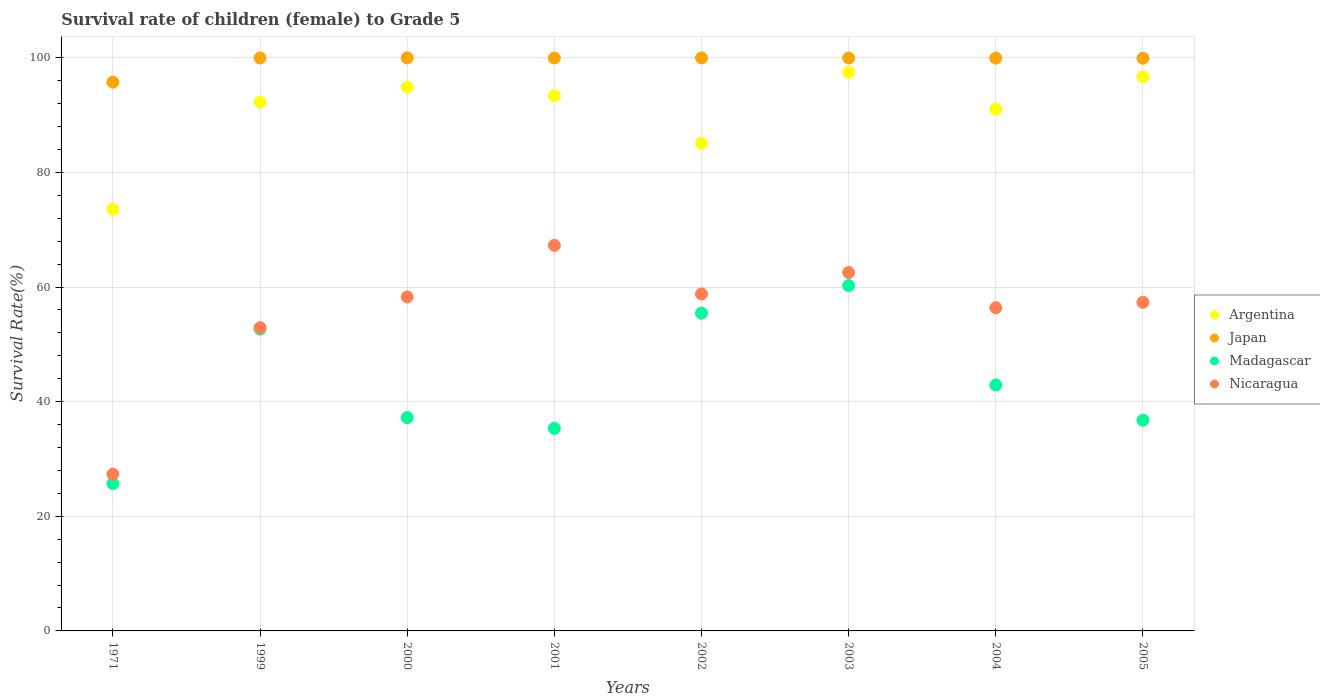How many different coloured dotlines are there?
Keep it short and to the point. 4. Is the number of dotlines equal to the number of legend labels?
Provide a short and direct response. Yes. What is the survival rate of female children to grade 5 in Argentina in 2000?
Your response must be concise. 94.89. Across all years, what is the maximum survival rate of female children to grade 5 in Argentina?
Keep it short and to the point. 97.47. Across all years, what is the minimum survival rate of female children to grade 5 in Madagascar?
Your response must be concise. 25.71. In which year was the survival rate of female children to grade 5 in Madagascar minimum?
Make the answer very short. 1971. What is the total survival rate of female children to grade 5 in Japan in the graph?
Ensure brevity in your answer.  795.5. What is the difference between the survival rate of female children to grade 5 in Japan in 2002 and that in 2004?
Provide a short and direct response. 0.04. What is the difference between the survival rate of female children to grade 5 in Argentina in 2003 and the survival rate of female children to grade 5 in Nicaragua in 2005?
Ensure brevity in your answer.  40.14. What is the average survival rate of female children to grade 5 in Argentina per year?
Your answer should be compact. 90.55. In the year 1999, what is the difference between the survival rate of female children to grade 5 in Madagascar and survival rate of female children to grade 5 in Japan?
Keep it short and to the point. -47.32. What is the ratio of the survival rate of female children to grade 5 in Japan in 2000 to that in 2005?
Provide a succinct answer. 1. Is the survival rate of female children to grade 5 in Japan in 1999 less than that in 2001?
Your answer should be very brief. No. What is the difference between the highest and the second highest survival rate of female children to grade 5 in Nicaragua?
Your answer should be very brief. 4.74. What is the difference between the highest and the lowest survival rate of female children to grade 5 in Argentina?
Give a very brief answer. 23.9. In how many years, is the survival rate of female children to grade 5 in Nicaragua greater than the average survival rate of female children to grade 5 in Nicaragua taken over all years?
Your response must be concise. 6. Is it the case that in every year, the sum of the survival rate of female children to grade 5 in Japan and survival rate of female children to grade 5 in Nicaragua  is greater than the survival rate of female children to grade 5 in Argentina?
Offer a terse response. Yes. Does the survival rate of female children to grade 5 in Japan monotonically increase over the years?
Provide a short and direct response. No. Is the survival rate of female children to grade 5 in Argentina strictly greater than the survival rate of female children to grade 5 in Nicaragua over the years?
Your answer should be very brief. Yes. Is the survival rate of female children to grade 5 in Nicaragua strictly less than the survival rate of female children to grade 5 in Argentina over the years?
Keep it short and to the point. Yes. How many years are there in the graph?
Offer a terse response. 8. Are the values on the major ticks of Y-axis written in scientific E-notation?
Offer a very short reply. No. Does the graph contain grids?
Keep it short and to the point. Yes. Where does the legend appear in the graph?
Give a very brief answer. Center right. How many legend labels are there?
Your answer should be very brief. 4. What is the title of the graph?
Your answer should be very brief. Survival rate of children (female) to Grade 5. What is the label or title of the X-axis?
Offer a very short reply. Years. What is the label or title of the Y-axis?
Provide a succinct answer. Survival Rate(%). What is the Survival Rate(%) in Argentina in 1971?
Give a very brief answer. 73.58. What is the Survival Rate(%) of Japan in 1971?
Provide a succinct answer. 95.75. What is the Survival Rate(%) in Madagascar in 1971?
Provide a short and direct response. 25.71. What is the Survival Rate(%) of Nicaragua in 1971?
Keep it short and to the point. 27.36. What is the Survival Rate(%) in Argentina in 1999?
Provide a succinct answer. 92.27. What is the Survival Rate(%) of Japan in 1999?
Keep it short and to the point. 99.98. What is the Survival Rate(%) in Madagascar in 1999?
Provide a short and direct response. 52.66. What is the Survival Rate(%) in Nicaragua in 1999?
Provide a succinct answer. 52.92. What is the Survival Rate(%) in Argentina in 2000?
Provide a succinct answer. 94.89. What is the Survival Rate(%) of Japan in 2000?
Ensure brevity in your answer.  99.99. What is the Survival Rate(%) in Madagascar in 2000?
Your response must be concise. 37.22. What is the Survival Rate(%) of Nicaragua in 2000?
Give a very brief answer. 58.27. What is the Survival Rate(%) of Argentina in 2001?
Make the answer very short. 93.36. What is the Survival Rate(%) in Japan in 2001?
Make the answer very short. 99.96. What is the Survival Rate(%) of Madagascar in 2001?
Your answer should be very brief. 35.35. What is the Survival Rate(%) of Nicaragua in 2001?
Make the answer very short. 67.28. What is the Survival Rate(%) in Argentina in 2002?
Offer a terse response. 85.08. What is the Survival Rate(%) in Japan in 2002?
Your answer should be very brief. 99.98. What is the Survival Rate(%) in Madagascar in 2002?
Give a very brief answer. 55.45. What is the Survival Rate(%) in Nicaragua in 2002?
Offer a very short reply. 58.8. What is the Survival Rate(%) of Argentina in 2003?
Keep it short and to the point. 97.47. What is the Survival Rate(%) of Japan in 2003?
Offer a very short reply. 99.97. What is the Survival Rate(%) in Madagascar in 2003?
Your answer should be very brief. 60.26. What is the Survival Rate(%) of Nicaragua in 2003?
Offer a terse response. 62.54. What is the Survival Rate(%) of Argentina in 2004?
Provide a succinct answer. 91.02. What is the Survival Rate(%) in Japan in 2004?
Your answer should be compact. 99.94. What is the Survival Rate(%) in Madagascar in 2004?
Ensure brevity in your answer.  42.91. What is the Survival Rate(%) in Nicaragua in 2004?
Offer a very short reply. 56.39. What is the Survival Rate(%) in Argentina in 2005?
Your response must be concise. 96.71. What is the Survival Rate(%) in Japan in 2005?
Offer a very short reply. 99.92. What is the Survival Rate(%) of Madagascar in 2005?
Your response must be concise. 36.77. What is the Survival Rate(%) in Nicaragua in 2005?
Offer a very short reply. 57.34. Across all years, what is the maximum Survival Rate(%) in Argentina?
Your answer should be compact. 97.47. Across all years, what is the maximum Survival Rate(%) of Japan?
Offer a terse response. 99.99. Across all years, what is the maximum Survival Rate(%) in Madagascar?
Offer a terse response. 60.26. Across all years, what is the maximum Survival Rate(%) in Nicaragua?
Give a very brief answer. 67.28. Across all years, what is the minimum Survival Rate(%) in Argentina?
Your response must be concise. 73.58. Across all years, what is the minimum Survival Rate(%) in Japan?
Ensure brevity in your answer.  95.75. Across all years, what is the minimum Survival Rate(%) in Madagascar?
Offer a very short reply. 25.71. Across all years, what is the minimum Survival Rate(%) in Nicaragua?
Provide a succinct answer. 27.36. What is the total Survival Rate(%) in Argentina in the graph?
Your answer should be very brief. 724.39. What is the total Survival Rate(%) in Japan in the graph?
Provide a short and direct response. 795.5. What is the total Survival Rate(%) in Madagascar in the graph?
Keep it short and to the point. 346.33. What is the total Survival Rate(%) of Nicaragua in the graph?
Offer a terse response. 440.89. What is the difference between the Survival Rate(%) of Argentina in 1971 and that in 1999?
Provide a short and direct response. -18.7. What is the difference between the Survival Rate(%) of Japan in 1971 and that in 1999?
Provide a short and direct response. -4.22. What is the difference between the Survival Rate(%) of Madagascar in 1971 and that in 1999?
Keep it short and to the point. -26.95. What is the difference between the Survival Rate(%) of Nicaragua in 1971 and that in 1999?
Give a very brief answer. -25.56. What is the difference between the Survival Rate(%) of Argentina in 1971 and that in 2000?
Offer a terse response. -21.31. What is the difference between the Survival Rate(%) of Japan in 1971 and that in 2000?
Give a very brief answer. -4.24. What is the difference between the Survival Rate(%) in Madagascar in 1971 and that in 2000?
Offer a terse response. -11.51. What is the difference between the Survival Rate(%) in Nicaragua in 1971 and that in 2000?
Your response must be concise. -30.91. What is the difference between the Survival Rate(%) of Argentina in 1971 and that in 2001?
Provide a short and direct response. -19.79. What is the difference between the Survival Rate(%) in Japan in 1971 and that in 2001?
Give a very brief answer. -4.21. What is the difference between the Survival Rate(%) of Madagascar in 1971 and that in 2001?
Offer a very short reply. -9.64. What is the difference between the Survival Rate(%) of Nicaragua in 1971 and that in 2001?
Make the answer very short. -39.92. What is the difference between the Survival Rate(%) of Argentina in 1971 and that in 2002?
Make the answer very short. -11.51. What is the difference between the Survival Rate(%) of Japan in 1971 and that in 2002?
Your answer should be compact. -4.23. What is the difference between the Survival Rate(%) of Madagascar in 1971 and that in 2002?
Give a very brief answer. -29.74. What is the difference between the Survival Rate(%) of Nicaragua in 1971 and that in 2002?
Your answer should be compact. -31.44. What is the difference between the Survival Rate(%) in Argentina in 1971 and that in 2003?
Make the answer very short. -23.9. What is the difference between the Survival Rate(%) in Japan in 1971 and that in 2003?
Offer a very short reply. -4.22. What is the difference between the Survival Rate(%) of Madagascar in 1971 and that in 2003?
Keep it short and to the point. -34.55. What is the difference between the Survival Rate(%) of Nicaragua in 1971 and that in 2003?
Your answer should be compact. -35.18. What is the difference between the Survival Rate(%) in Argentina in 1971 and that in 2004?
Make the answer very short. -17.45. What is the difference between the Survival Rate(%) in Japan in 1971 and that in 2004?
Keep it short and to the point. -4.19. What is the difference between the Survival Rate(%) in Madagascar in 1971 and that in 2004?
Keep it short and to the point. -17.2. What is the difference between the Survival Rate(%) of Nicaragua in 1971 and that in 2004?
Give a very brief answer. -29.03. What is the difference between the Survival Rate(%) of Argentina in 1971 and that in 2005?
Provide a succinct answer. -23.14. What is the difference between the Survival Rate(%) of Japan in 1971 and that in 2005?
Your answer should be compact. -4.17. What is the difference between the Survival Rate(%) of Madagascar in 1971 and that in 2005?
Offer a very short reply. -11.05. What is the difference between the Survival Rate(%) in Nicaragua in 1971 and that in 2005?
Your response must be concise. -29.98. What is the difference between the Survival Rate(%) of Argentina in 1999 and that in 2000?
Your answer should be very brief. -2.62. What is the difference between the Survival Rate(%) in Japan in 1999 and that in 2000?
Keep it short and to the point. -0.02. What is the difference between the Survival Rate(%) of Madagascar in 1999 and that in 2000?
Provide a short and direct response. 15.44. What is the difference between the Survival Rate(%) of Nicaragua in 1999 and that in 2000?
Give a very brief answer. -5.35. What is the difference between the Survival Rate(%) of Argentina in 1999 and that in 2001?
Offer a terse response. -1.09. What is the difference between the Survival Rate(%) of Japan in 1999 and that in 2001?
Make the answer very short. 0.01. What is the difference between the Survival Rate(%) of Madagascar in 1999 and that in 2001?
Give a very brief answer. 17.31. What is the difference between the Survival Rate(%) of Nicaragua in 1999 and that in 2001?
Make the answer very short. -14.36. What is the difference between the Survival Rate(%) in Argentina in 1999 and that in 2002?
Your response must be concise. 7.19. What is the difference between the Survival Rate(%) in Japan in 1999 and that in 2002?
Make the answer very short. -0. What is the difference between the Survival Rate(%) in Madagascar in 1999 and that in 2002?
Provide a succinct answer. -2.79. What is the difference between the Survival Rate(%) of Nicaragua in 1999 and that in 2002?
Provide a succinct answer. -5.88. What is the difference between the Survival Rate(%) of Argentina in 1999 and that in 2003?
Keep it short and to the point. -5.2. What is the difference between the Survival Rate(%) of Japan in 1999 and that in 2003?
Keep it short and to the point. 0. What is the difference between the Survival Rate(%) of Madagascar in 1999 and that in 2003?
Your answer should be very brief. -7.6. What is the difference between the Survival Rate(%) in Nicaragua in 1999 and that in 2003?
Make the answer very short. -9.62. What is the difference between the Survival Rate(%) in Argentina in 1999 and that in 2004?
Provide a short and direct response. 1.25. What is the difference between the Survival Rate(%) of Japan in 1999 and that in 2004?
Give a very brief answer. 0.03. What is the difference between the Survival Rate(%) of Madagascar in 1999 and that in 2004?
Give a very brief answer. 9.75. What is the difference between the Survival Rate(%) of Nicaragua in 1999 and that in 2004?
Offer a very short reply. -3.47. What is the difference between the Survival Rate(%) of Argentina in 1999 and that in 2005?
Provide a succinct answer. -4.44. What is the difference between the Survival Rate(%) in Japan in 1999 and that in 2005?
Your answer should be compact. 0.06. What is the difference between the Survival Rate(%) in Madagascar in 1999 and that in 2005?
Provide a short and direct response. 15.89. What is the difference between the Survival Rate(%) in Nicaragua in 1999 and that in 2005?
Keep it short and to the point. -4.42. What is the difference between the Survival Rate(%) of Argentina in 2000 and that in 2001?
Your response must be concise. 1.53. What is the difference between the Survival Rate(%) in Japan in 2000 and that in 2001?
Give a very brief answer. 0.03. What is the difference between the Survival Rate(%) of Madagascar in 2000 and that in 2001?
Offer a very short reply. 1.87. What is the difference between the Survival Rate(%) in Nicaragua in 2000 and that in 2001?
Offer a very short reply. -9. What is the difference between the Survival Rate(%) of Argentina in 2000 and that in 2002?
Provide a succinct answer. 9.81. What is the difference between the Survival Rate(%) in Japan in 2000 and that in 2002?
Ensure brevity in your answer.  0.01. What is the difference between the Survival Rate(%) of Madagascar in 2000 and that in 2002?
Offer a very short reply. -18.23. What is the difference between the Survival Rate(%) in Nicaragua in 2000 and that in 2002?
Keep it short and to the point. -0.52. What is the difference between the Survival Rate(%) in Argentina in 2000 and that in 2003?
Your response must be concise. -2.59. What is the difference between the Survival Rate(%) of Japan in 2000 and that in 2003?
Provide a short and direct response. 0.02. What is the difference between the Survival Rate(%) of Madagascar in 2000 and that in 2003?
Give a very brief answer. -23.04. What is the difference between the Survival Rate(%) in Nicaragua in 2000 and that in 2003?
Offer a very short reply. -4.26. What is the difference between the Survival Rate(%) of Argentina in 2000 and that in 2004?
Give a very brief answer. 3.86. What is the difference between the Survival Rate(%) of Japan in 2000 and that in 2004?
Offer a very short reply. 0.05. What is the difference between the Survival Rate(%) in Madagascar in 2000 and that in 2004?
Make the answer very short. -5.69. What is the difference between the Survival Rate(%) in Nicaragua in 2000 and that in 2004?
Give a very brief answer. 1.88. What is the difference between the Survival Rate(%) in Argentina in 2000 and that in 2005?
Provide a succinct answer. -1.83. What is the difference between the Survival Rate(%) in Japan in 2000 and that in 2005?
Provide a succinct answer. 0.07. What is the difference between the Survival Rate(%) of Madagascar in 2000 and that in 2005?
Give a very brief answer. 0.45. What is the difference between the Survival Rate(%) in Nicaragua in 2000 and that in 2005?
Make the answer very short. 0.94. What is the difference between the Survival Rate(%) of Argentina in 2001 and that in 2002?
Ensure brevity in your answer.  8.28. What is the difference between the Survival Rate(%) in Japan in 2001 and that in 2002?
Your answer should be very brief. -0.02. What is the difference between the Survival Rate(%) of Madagascar in 2001 and that in 2002?
Make the answer very short. -20.1. What is the difference between the Survival Rate(%) in Nicaragua in 2001 and that in 2002?
Your answer should be compact. 8.48. What is the difference between the Survival Rate(%) in Argentina in 2001 and that in 2003?
Your answer should be compact. -4.11. What is the difference between the Survival Rate(%) of Japan in 2001 and that in 2003?
Offer a very short reply. -0.01. What is the difference between the Survival Rate(%) in Madagascar in 2001 and that in 2003?
Keep it short and to the point. -24.91. What is the difference between the Survival Rate(%) of Nicaragua in 2001 and that in 2003?
Ensure brevity in your answer.  4.74. What is the difference between the Survival Rate(%) in Argentina in 2001 and that in 2004?
Provide a short and direct response. 2.34. What is the difference between the Survival Rate(%) of Japan in 2001 and that in 2004?
Make the answer very short. 0.02. What is the difference between the Survival Rate(%) of Madagascar in 2001 and that in 2004?
Your response must be concise. -7.56. What is the difference between the Survival Rate(%) in Nicaragua in 2001 and that in 2004?
Keep it short and to the point. 10.89. What is the difference between the Survival Rate(%) in Argentina in 2001 and that in 2005?
Your answer should be compact. -3.35. What is the difference between the Survival Rate(%) of Japan in 2001 and that in 2005?
Your answer should be very brief. 0.04. What is the difference between the Survival Rate(%) of Madagascar in 2001 and that in 2005?
Your response must be concise. -1.42. What is the difference between the Survival Rate(%) of Nicaragua in 2001 and that in 2005?
Your answer should be compact. 9.94. What is the difference between the Survival Rate(%) of Argentina in 2002 and that in 2003?
Your answer should be very brief. -12.39. What is the difference between the Survival Rate(%) of Japan in 2002 and that in 2003?
Keep it short and to the point. 0.01. What is the difference between the Survival Rate(%) in Madagascar in 2002 and that in 2003?
Give a very brief answer. -4.82. What is the difference between the Survival Rate(%) in Nicaragua in 2002 and that in 2003?
Your answer should be very brief. -3.74. What is the difference between the Survival Rate(%) in Argentina in 2002 and that in 2004?
Make the answer very short. -5.94. What is the difference between the Survival Rate(%) in Japan in 2002 and that in 2004?
Your response must be concise. 0.04. What is the difference between the Survival Rate(%) of Madagascar in 2002 and that in 2004?
Your answer should be compact. 12.54. What is the difference between the Survival Rate(%) of Nicaragua in 2002 and that in 2004?
Ensure brevity in your answer.  2.41. What is the difference between the Survival Rate(%) of Argentina in 2002 and that in 2005?
Offer a very short reply. -11.63. What is the difference between the Survival Rate(%) of Japan in 2002 and that in 2005?
Offer a terse response. 0.06. What is the difference between the Survival Rate(%) in Madagascar in 2002 and that in 2005?
Give a very brief answer. 18.68. What is the difference between the Survival Rate(%) in Nicaragua in 2002 and that in 2005?
Offer a very short reply. 1.46. What is the difference between the Survival Rate(%) in Argentina in 2003 and that in 2004?
Provide a succinct answer. 6.45. What is the difference between the Survival Rate(%) in Japan in 2003 and that in 2004?
Offer a terse response. 0.03. What is the difference between the Survival Rate(%) in Madagascar in 2003 and that in 2004?
Your answer should be compact. 17.35. What is the difference between the Survival Rate(%) of Nicaragua in 2003 and that in 2004?
Provide a short and direct response. 6.15. What is the difference between the Survival Rate(%) in Argentina in 2003 and that in 2005?
Your response must be concise. 0.76. What is the difference between the Survival Rate(%) of Japan in 2003 and that in 2005?
Your answer should be very brief. 0.05. What is the difference between the Survival Rate(%) of Madagascar in 2003 and that in 2005?
Provide a short and direct response. 23.5. What is the difference between the Survival Rate(%) of Argentina in 2004 and that in 2005?
Provide a succinct answer. -5.69. What is the difference between the Survival Rate(%) in Japan in 2004 and that in 2005?
Keep it short and to the point. 0.02. What is the difference between the Survival Rate(%) in Madagascar in 2004 and that in 2005?
Your answer should be compact. 6.15. What is the difference between the Survival Rate(%) of Nicaragua in 2004 and that in 2005?
Ensure brevity in your answer.  -0.95. What is the difference between the Survival Rate(%) in Argentina in 1971 and the Survival Rate(%) in Japan in 1999?
Your answer should be compact. -26.4. What is the difference between the Survival Rate(%) of Argentina in 1971 and the Survival Rate(%) of Madagascar in 1999?
Your response must be concise. 20.91. What is the difference between the Survival Rate(%) of Argentina in 1971 and the Survival Rate(%) of Nicaragua in 1999?
Provide a succinct answer. 20.66. What is the difference between the Survival Rate(%) of Japan in 1971 and the Survival Rate(%) of Madagascar in 1999?
Provide a short and direct response. 43.09. What is the difference between the Survival Rate(%) in Japan in 1971 and the Survival Rate(%) in Nicaragua in 1999?
Your response must be concise. 42.83. What is the difference between the Survival Rate(%) of Madagascar in 1971 and the Survival Rate(%) of Nicaragua in 1999?
Your answer should be compact. -27.21. What is the difference between the Survival Rate(%) of Argentina in 1971 and the Survival Rate(%) of Japan in 2000?
Provide a succinct answer. -26.42. What is the difference between the Survival Rate(%) in Argentina in 1971 and the Survival Rate(%) in Madagascar in 2000?
Give a very brief answer. 36.36. What is the difference between the Survival Rate(%) in Argentina in 1971 and the Survival Rate(%) in Nicaragua in 2000?
Offer a terse response. 15.3. What is the difference between the Survival Rate(%) of Japan in 1971 and the Survival Rate(%) of Madagascar in 2000?
Provide a short and direct response. 58.53. What is the difference between the Survival Rate(%) of Japan in 1971 and the Survival Rate(%) of Nicaragua in 2000?
Offer a very short reply. 37.48. What is the difference between the Survival Rate(%) in Madagascar in 1971 and the Survival Rate(%) in Nicaragua in 2000?
Your answer should be very brief. -32.56. What is the difference between the Survival Rate(%) of Argentina in 1971 and the Survival Rate(%) of Japan in 2001?
Offer a very short reply. -26.39. What is the difference between the Survival Rate(%) of Argentina in 1971 and the Survival Rate(%) of Madagascar in 2001?
Offer a terse response. 38.23. What is the difference between the Survival Rate(%) in Argentina in 1971 and the Survival Rate(%) in Nicaragua in 2001?
Your response must be concise. 6.3. What is the difference between the Survival Rate(%) of Japan in 1971 and the Survival Rate(%) of Madagascar in 2001?
Your answer should be very brief. 60.4. What is the difference between the Survival Rate(%) of Japan in 1971 and the Survival Rate(%) of Nicaragua in 2001?
Give a very brief answer. 28.47. What is the difference between the Survival Rate(%) in Madagascar in 1971 and the Survival Rate(%) in Nicaragua in 2001?
Provide a succinct answer. -41.57. What is the difference between the Survival Rate(%) of Argentina in 1971 and the Survival Rate(%) of Japan in 2002?
Ensure brevity in your answer.  -26.4. What is the difference between the Survival Rate(%) of Argentina in 1971 and the Survival Rate(%) of Madagascar in 2002?
Offer a terse response. 18.13. What is the difference between the Survival Rate(%) of Argentina in 1971 and the Survival Rate(%) of Nicaragua in 2002?
Offer a terse response. 14.78. What is the difference between the Survival Rate(%) of Japan in 1971 and the Survival Rate(%) of Madagascar in 2002?
Provide a short and direct response. 40.3. What is the difference between the Survival Rate(%) in Japan in 1971 and the Survival Rate(%) in Nicaragua in 2002?
Offer a terse response. 36.95. What is the difference between the Survival Rate(%) of Madagascar in 1971 and the Survival Rate(%) of Nicaragua in 2002?
Your response must be concise. -33.09. What is the difference between the Survival Rate(%) in Argentina in 1971 and the Survival Rate(%) in Japan in 2003?
Offer a very short reply. -26.4. What is the difference between the Survival Rate(%) in Argentina in 1971 and the Survival Rate(%) in Madagascar in 2003?
Make the answer very short. 13.31. What is the difference between the Survival Rate(%) in Argentina in 1971 and the Survival Rate(%) in Nicaragua in 2003?
Offer a terse response. 11.04. What is the difference between the Survival Rate(%) of Japan in 1971 and the Survival Rate(%) of Madagascar in 2003?
Your answer should be very brief. 35.49. What is the difference between the Survival Rate(%) in Japan in 1971 and the Survival Rate(%) in Nicaragua in 2003?
Ensure brevity in your answer.  33.21. What is the difference between the Survival Rate(%) in Madagascar in 1971 and the Survival Rate(%) in Nicaragua in 2003?
Your answer should be compact. -36.83. What is the difference between the Survival Rate(%) in Argentina in 1971 and the Survival Rate(%) in Japan in 2004?
Your answer should be very brief. -26.37. What is the difference between the Survival Rate(%) in Argentina in 1971 and the Survival Rate(%) in Madagascar in 2004?
Keep it short and to the point. 30.66. What is the difference between the Survival Rate(%) in Argentina in 1971 and the Survival Rate(%) in Nicaragua in 2004?
Keep it short and to the point. 17.19. What is the difference between the Survival Rate(%) of Japan in 1971 and the Survival Rate(%) of Madagascar in 2004?
Ensure brevity in your answer.  52.84. What is the difference between the Survival Rate(%) of Japan in 1971 and the Survival Rate(%) of Nicaragua in 2004?
Keep it short and to the point. 39.36. What is the difference between the Survival Rate(%) in Madagascar in 1971 and the Survival Rate(%) in Nicaragua in 2004?
Keep it short and to the point. -30.68. What is the difference between the Survival Rate(%) in Argentina in 1971 and the Survival Rate(%) in Japan in 2005?
Your response must be concise. -26.35. What is the difference between the Survival Rate(%) in Argentina in 1971 and the Survival Rate(%) in Madagascar in 2005?
Make the answer very short. 36.81. What is the difference between the Survival Rate(%) in Argentina in 1971 and the Survival Rate(%) in Nicaragua in 2005?
Provide a succinct answer. 16.24. What is the difference between the Survival Rate(%) in Japan in 1971 and the Survival Rate(%) in Madagascar in 2005?
Provide a succinct answer. 58.99. What is the difference between the Survival Rate(%) of Japan in 1971 and the Survival Rate(%) of Nicaragua in 2005?
Offer a very short reply. 38.41. What is the difference between the Survival Rate(%) of Madagascar in 1971 and the Survival Rate(%) of Nicaragua in 2005?
Your response must be concise. -31.63. What is the difference between the Survival Rate(%) of Argentina in 1999 and the Survival Rate(%) of Japan in 2000?
Ensure brevity in your answer.  -7.72. What is the difference between the Survival Rate(%) of Argentina in 1999 and the Survival Rate(%) of Madagascar in 2000?
Provide a short and direct response. 55.05. What is the difference between the Survival Rate(%) in Argentina in 1999 and the Survival Rate(%) in Nicaragua in 2000?
Provide a succinct answer. 34. What is the difference between the Survival Rate(%) in Japan in 1999 and the Survival Rate(%) in Madagascar in 2000?
Provide a succinct answer. 62.76. What is the difference between the Survival Rate(%) in Japan in 1999 and the Survival Rate(%) in Nicaragua in 2000?
Keep it short and to the point. 41.7. What is the difference between the Survival Rate(%) of Madagascar in 1999 and the Survival Rate(%) of Nicaragua in 2000?
Offer a very short reply. -5.61. What is the difference between the Survival Rate(%) of Argentina in 1999 and the Survival Rate(%) of Japan in 2001?
Offer a terse response. -7.69. What is the difference between the Survival Rate(%) of Argentina in 1999 and the Survival Rate(%) of Madagascar in 2001?
Offer a terse response. 56.92. What is the difference between the Survival Rate(%) of Argentina in 1999 and the Survival Rate(%) of Nicaragua in 2001?
Offer a terse response. 24.99. What is the difference between the Survival Rate(%) of Japan in 1999 and the Survival Rate(%) of Madagascar in 2001?
Offer a terse response. 64.63. What is the difference between the Survival Rate(%) in Japan in 1999 and the Survival Rate(%) in Nicaragua in 2001?
Your answer should be compact. 32.7. What is the difference between the Survival Rate(%) in Madagascar in 1999 and the Survival Rate(%) in Nicaragua in 2001?
Offer a terse response. -14.62. What is the difference between the Survival Rate(%) in Argentina in 1999 and the Survival Rate(%) in Japan in 2002?
Offer a terse response. -7.71. What is the difference between the Survival Rate(%) of Argentina in 1999 and the Survival Rate(%) of Madagascar in 2002?
Provide a short and direct response. 36.82. What is the difference between the Survival Rate(%) of Argentina in 1999 and the Survival Rate(%) of Nicaragua in 2002?
Provide a short and direct response. 33.47. What is the difference between the Survival Rate(%) in Japan in 1999 and the Survival Rate(%) in Madagascar in 2002?
Your response must be concise. 44.53. What is the difference between the Survival Rate(%) in Japan in 1999 and the Survival Rate(%) in Nicaragua in 2002?
Your answer should be very brief. 41.18. What is the difference between the Survival Rate(%) of Madagascar in 1999 and the Survival Rate(%) of Nicaragua in 2002?
Give a very brief answer. -6.14. What is the difference between the Survival Rate(%) in Argentina in 1999 and the Survival Rate(%) in Japan in 2003?
Offer a very short reply. -7.7. What is the difference between the Survival Rate(%) of Argentina in 1999 and the Survival Rate(%) of Madagascar in 2003?
Give a very brief answer. 32.01. What is the difference between the Survival Rate(%) in Argentina in 1999 and the Survival Rate(%) in Nicaragua in 2003?
Your answer should be very brief. 29.73. What is the difference between the Survival Rate(%) in Japan in 1999 and the Survival Rate(%) in Madagascar in 2003?
Offer a terse response. 39.71. What is the difference between the Survival Rate(%) of Japan in 1999 and the Survival Rate(%) of Nicaragua in 2003?
Keep it short and to the point. 37.44. What is the difference between the Survival Rate(%) in Madagascar in 1999 and the Survival Rate(%) in Nicaragua in 2003?
Your answer should be very brief. -9.88. What is the difference between the Survival Rate(%) in Argentina in 1999 and the Survival Rate(%) in Japan in 2004?
Give a very brief answer. -7.67. What is the difference between the Survival Rate(%) in Argentina in 1999 and the Survival Rate(%) in Madagascar in 2004?
Make the answer very short. 49.36. What is the difference between the Survival Rate(%) of Argentina in 1999 and the Survival Rate(%) of Nicaragua in 2004?
Offer a terse response. 35.88. What is the difference between the Survival Rate(%) in Japan in 1999 and the Survival Rate(%) in Madagascar in 2004?
Ensure brevity in your answer.  57.06. What is the difference between the Survival Rate(%) of Japan in 1999 and the Survival Rate(%) of Nicaragua in 2004?
Your answer should be compact. 43.59. What is the difference between the Survival Rate(%) of Madagascar in 1999 and the Survival Rate(%) of Nicaragua in 2004?
Ensure brevity in your answer.  -3.73. What is the difference between the Survival Rate(%) in Argentina in 1999 and the Survival Rate(%) in Japan in 2005?
Offer a very short reply. -7.65. What is the difference between the Survival Rate(%) of Argentina in 1999 and the Survival Rate(%) of Madagascar in 2005?
Keep it short and to the point. 55.51. What is the difference between the Survival Rate(%) of Argentina in 1999 and the Survival Rate(%) of Nicaragua in 2005?
Offer a terse response. 34.93. What is the difference between the Survival Rate(%) in Japan in 1999 and the Survival Rate(%) in Madagascar in 2005?
Keep it short and to the point. 63.21. What is the difference between the Survival Rate(%) in Japan in 1999 and the Survival Rate(%) in Nicaragua in 2005?
Provide a succinct answer. 42.64. What is the difference between the Survival Rate(%) in Madagascar in 1999 and the Survival Rate(%) in Nicaragua in 2005?
Offer a very short reply. -4.68. What is the difference between the Survival Rate(%) in Argentina in 2000 and the Survival Rate(%) in Japan in 2001?
Offer a very short reply. -5.07. What is the difference between the Survival Rate(%) in Argentina in 2000 and the Survival Rate(%) in Madagascar in 2001?
Offer a terse response. 59.54. What is the difference between the Survival Rate(%) of Argentina in 2000 and the Survival Rate(%) of Nicaragua in 2001?
Your answer should be compact. 27.61. What is the difference between the Survival Rate(%) in Japan in 2000 and the Survival Rate(%) in Madagascar in 2001?
Provide a succinct answer. 64.64. What is the difference between the Survival Rate(%) in Japan in 2000 and the Survival Rate(%) in Nicaragua in 2001?
Your answer should be very brief. 32.71. What is the difference between the Survival Rate(%) in Madagascar in 2000 and the Survival Rate(%) in Nicaragua in 2001?
Your answer should be very brief. -30.06. What is the difference between the Survival Rate(%) in Argentina in 2000 and the Survival Rate(%) in Japan in 2002?
Your answer should be compact. -5.09. What is the difference between the Survival Rate(%) in Argentina in 2000 and the Survival Rate(%) in Madagascar in 2002?
Your answer should be compact. 39.44. What is the difference between the Survival Rate(%) of Argentina in 2000 and the Survival Rate(%) of Nicaragua in 2002?
Your response must be concise. 36.09. What is the difference between the Survival Rate(%) in Japan in 2000 and the Survival Rate(%) in Madagascar in 2002?
Provide a short and direct response. 44.54. What is the difference between the Survival Rate(%) in Japan in 2000 and the Survival Rate(%) in Nicaragua in 2002?
Give a very brief answer. 41.19. What is the difference between the Survival Rate(%) of Madagascar in 2000 and the Survival Rate(%) of Nicaragua in 2002?
Give a very brief answer. -21.58. What is the difference between the Survival Rate(%) of Argentina in 2000 and the Survival Rate(%) of Japan in 2003?
Provide a succinct answer. -5.09. What is the difference between the Survival Rate(%) of Argentina in 2000 and the Survival Rate(%) of Madagascar in 2003?
Make the answer very short. 34.62. What is the difference between the Survival Rate(%) of Argentina in 2000 and the Survival Rate(%) of Nicaragua in 2003?
Offer a very short reply. 32.35. What is the difference between the Survival Rate(%) of Japan in 2000 and the Survival Rate(%) of Madagascar in 2003?
Provide a short and direct response. 39.73. What is the difference between the Survival Rate(%) in Japan in 2000 and the Survival Rate(%) in Nicaragua in 2003?
Provide a succinct answer. 37.45. What is the difference between the Survival Rate(%) of Madagascar in 2000 and the Survival Rate(%) of Nicaragua in 2003?
Make the answer very short. -25.32. What is the difference between the Survival Rate(%) in Argentina in 2000 and the Survival Rate(%) in Japan in 2004?
Your response must be concise. -5.06. What is the difference between the Survival Rate(%) of Argentina in 2000 and the Survival Rate(%) of Madagascar in 2004?
Ensure brevity in your answer.  51.98. What is the difference between the Survival Rate(%) of Argentina in 2000 and the Survival Rate(%) of Nicaragua in 2004?
Your answer should be compact. 38.5. What is the difference between the Survival Rate(%) of Japan in 2000 and the Survival Rate(%) of Madagascar in 2004?
Provide a succinct answer. 57.08. What is the difference between the Survival Rate(%) in Japan in 2000 and the Survival Rate(%) in Nicaragua in 2004?
Your answer should be compact. 43.6. What is the difference between the Survival Rate(%) of Madagascar in 2000 and the Survival Rate(%) of Nicaragua in 2004?
Your answer should be very brief. -19.17. What is the difference between the Survival Rate(%) in Argentina in 2000 and the Survival Rate(%) in Japan in 2005?
Ensure brevity in your answer.  -5.03. What is the difference between the Survival Rate(%) in Argentina in 2000 and the Survival Rate(%) in Madagascar in 2005?
Your response must be concise. 58.12. What is the difference between the Survival Rate(%) in Argentina in 2000 and the Survival Rate(%) in Nicaragua in 2005?
Ensure brevity in your answer.  37.55. What is the difference between the Survival Rate(%) in Japan in 2000 and the Survival Rate(%) in Madagascar in 2005?
Ensure brevity in your answer.  63.23. What is the difference between the Survival Rate(%) of Japan in 2000 and the Survival Rate(%) of Nicaragua in 2005?
Offer a very short reply. 42.65. What is the difference between the Survival Rate(%) of Madagascar in 2000 and the Survival Rate(%) of Nicaragua in 2005?
Keep it short and to the point. -20.12. What is the difference between the Survival Rate(%) of Argentina in 2001 and the Survival Rate(%) of Japan in 2002?
Your answer should be very brief. -6.62. What is the difference between the Survival Rate(%) of Argentina in 2001 and the Survival Rate(%) of Madagascar in 2002?
Provide a succinct answer. 37.91. What is the difference between the Survival Rate(%) of Argentina in 2001 and the Survival Rate(%) of Nicaragua in 2002?
Make the answer very short. 34.56. What is the difference between the Survival Rate(%) in Japan in 2001 and the Survival Rate(%) in Madagascar in 2002?
Offer a very short reply. 44.51. What is the difference between the Survival Rate(%) in Japan in 2001 and the Survival Rate(%) in Nicaragua in 2002?
Ensure brevity in your answer.  41.16. What is the difference between the Survival Rate(%) in Madagascar in 2001 and the Survival Rate(%) in Nicaragua in 2002?
Give a very brief answer. -23.45. What is the difference between the Survival Rate(%) in Argentina in 2001 and the Survival Rate(%) in Japan in 2003?
Your response must be concise. -6.61. What is the difference between the Survival Rate(%) of Argentina in 2001 and the Survival Rate(%) of Madagascar in 2003?
Provide a short and direct response. 33.1. What is the difference between the Survival Rate(%) of Argentina in 2001 and the Survival Rate(%) of Nicaragua in 2003?
Give a very brief answer. 30.82. What is the difference between the Survival Rate(%) in Japan in 2001 and the Survival Rate(%) in Madagascar in 2003?
Offer a terse response. 39.7. What is the difference between the Survival Rate(%) of Japan in 2001 and the Survival Rate(%) of Nicaragua in 2003?
Offer a very short reply. 37.42. What is the difference between the Survival Rate(%) of Madagascar in 2001 and the Survival Rate(%) of Nicaragua in 2003?
Offer a terse response. -27.19. What is the difference between the Survival Rate(%) in Argentina in 2001 and the Survival Rate(%) in Japan in 2004?
Keep it short and to the point. -6.58. What is the difference between the Survival Rate(%) in Argentina in 2001 and the Survival Rate(%) in Madagascar in 2004?
Ensure brevity in your answer.  50.45. What is the difference between the Survival Rate(%) in Argentina in 2001 and the Survival Rate(%) in Nicaragua in 2004?
Your response must be concise. 36.97. What is the difference between the Survival Rate(%) in Japan in 2001 and the Survival Rate(%) in Madagascar in 2004?
Make the answer very short. 57.05. What is the difference between the Survival Rate(%) of Japan in 2001 and the Survival Rate(%) of Nicaragua in 2004?
Provide a short and direct response. 43.57. What is the difference between the Survival Rate(%) of Madagascar in 2001 and the Survival Rate(%) of Nicaragua in 2004?
Provide a short and direct response. -21.04. What is the difference between the Survival Rate(%) in Argentina in 2001 and the Survival Rate(%) in Japan in 2005?
Provide a succinct answer. -6.56. What is the difference between the Survival Rate(%) of Argentina in 2001 and the Survival Rate(%) of Madagascar in 2005?
Your answer should be very brief. 56.6. What is the difference between the Survival Rate(%) in Argentina in 2001 and the Survival Rate(%) in Nicaragua in 2005?
Ensure brevity in your answer.  36.02. What is the difference between the Survival Rate(%) in Japan in 2001 and the Survival Rate(%) in Madagascar in 2005?
Provide a succinct answer. 63.2. What is the difference between the Survival Rate(%) of Japan in 2001 and the Survival Rate(%) of Nicaragua in 2005?
Offer a terse response. 42.62. What is the difference between the Survival Rate(%) in Madagascar in 2001 and the Survival Rate(%) in Nicaragua in 2005?
Offer a very short reply. -21.99. What is the difference between the Survival Rate(%) of Argentina in 2002 and the Survival Rate(%) of Japan in 2003?
Offer a terse response. -14.89. What is the difference between the Survival Rate(%) of Argentina in 2002 and the Survival Rate(%) of Madagascar in 2003?
Ensure brevity in your answer.  24.82. What is the difference between the Survival Rate(%) of Argentina in 2002 and the Survival Rate(%) of Nicaragua in 2003?
Your answer should be compact. 22.54. What is the difference between the Survival Rate(%) of Japan in 2002 and the Survival Rate(%) of Madagascar in 2003?
Give a very brief answer. 39.72. What is the difference between the Survival Rate(%) in Japan in 2002 and the Survival Rate(%) in Nicaragua in 2003?
Provide a succinct answer. 37.44. What is the difference between the Survival Rate(%) of Madagascar in 2002 and the Survival Rate(%) of Nicaragua in 2003?
Provide a short and direct response. -7.09. What is the difference between the Survival Rate(%) of Argentina in 2002 and the Survival Rate(%) of Japan in 2004?
Ensure brevity in your answer.  -14.86. What is the difference between the Survival Rate(%) in Argentina in 2002 and the Survival Rate(%) in Madagascar in 2004?
Provide a short and direct response. 42.17. What is the difference between the Survival Rate(%) in Argentina in 2002 and the Survival Rate(%) in Nicaragua in 2004?
Provide a succinct answer. 28.69. What is the difference between the Survival Rate(%) in Japan in 2002 and the Survival Rate(%) in Madagascar in 2004?
Provide a short and direct response. 57.07. What is the difference between the Survival Rate(%) of Japan in 2002 and the Survival Rate(%) of Nicaragua in 2004?
Your answer should be compact. 43.59. What is the difference between the Survival Rate(%) in Madagascar in 2002 and the Survival Rate(%) in Nicaragua in 2004?
Your answer should be compact. -0.94. What is the difference between the Survival Rate(%) of Argentina in 2002 and the Survival Rate(%) of Japan in 2005?
Offer a terse response. -14.84. What is the difference between the Survival Rate(%) in Argentina in 2002 and the Survival Rate(%) in Madagascar in 2005?
Your answer should be compact. 48.32. What is the difference between the Survival Rate(%) of Argentina in 2002 and the Survival Rate(%) of Nicaragua in 2005?
Give a very brief answer. 27.74. What is the difference between the Survival Rate(%) of Japan in 2002 and the Survival Rate(%) of Madagascar in 2005?
Your answer should be very brief. 63.21. What is the difference between the Survival Rate(%) in Japan in 2002 and the Survival Rate(%) in Nicaragua in 2005?
Ensure brevity in your answer.  42.64. What is the difference between the Survival Rate(%) in Madagascar in 2002 and the Survival Rate(%) in Nicaragua in 2005?
Your answer should be compact. -1.89. What is the difference between the Survival Rate(%) of Argentina in 2003 and the Survival Rate(%) of Japan in 2004?
Offer a terse response. -2.47. What is the difference between the Survival Rate(%) in Argentina in 2003 and the Survival Rate(%) in Madagascar in 2004?
Offer a terse response. 54.56. What is the difference between the Survival Rate(%) in Argentina in 2003 and the Survival Rate(%) in Nicaragua in 2004?
Provide a succinct answer. 41.08. What is the difference between the Survival Rate(%) in Japan in 2003 and the Survival Rate(%) in Madagascar in 2004?
Provide a succinct answer. 57.06. What is the difference between the Survival Rate(%) in Japan in 2003 and the Survival Rate(%) in Nicaragua in 2004?
Offer a terse response. 43.59. What is the difference between the Survival Rate(%) of Madagascar in 2003 and the Survival Rate(%) of Nicaragua in 2004?
Your answer should be very brief. 3.88. What is the difference between the Survival Rate(%) in Argentina in 2003 and the Survival Rate(%) in Japan in 2005?
Make the answer very short. -2.45. What is the difference between the Survival Rate(%) of Argentina in 2003 and the Survival Rate(%) of Madagascar in 2005?
Provide a short and direct response. 60.71. What is the difference between the Survival Rate(%) in Argentina in 2003 and the Survival Rate(%) in Nicaragua in 2005?
Keep it short and to the point. 40.14. What is the difference between the Survival Rate(%) in Japan in 2003 and the Survival Rate(%) in Madagascar in 2005?
Your answer should be compact. 63.21. What is the difference between the Survival Rate(%) in Japan in 2003 and the Survival Rate(%) in Nicaragua in 2005?
Give a very brief answer. 42.64. What is the difference between the Survival Rate(%) in Madagascar in 2003 and the Survival Rate(%) in Nicaragua in 2005?
Keep it short and to the point. 2.93. What is the difference between the Survival Rate(%) in Argentina in 2004 and the Survival Rate(%) in Japan in 2005?
Make the answer very short. -8.9. What is the difference between the Survival Rate(%) of Argentina in 2004 and the Survival Rate(%) of Madagascar in 2005?
Give a very brief answer. 54.26. What is the difference between the Survival Rate(%) of Argentina in 2004 and the Survival Rate(%) of Nicaragua in 2005?
Your answer should be compact. 33.69. What is the difference between the Survival Rate(%) in Japan in 2004 and the Survival Rate(%) in Madagascar in 2005?
Offer a terse response. 63.18. What is the difference between the Survival Rate(%) of Japan in 2004 and the Survival Rate(%) of Nicaragua in 2005?
Your response must be concise. 42.61. What is the difference between the Survival Rate(%) in Madagascar in 2004 and the Survival Rate(%) in Nicaragua in 2005?
Give a very brief answer. -14.43. What is the average Survival Rate(%) of Argentina per year?
Ensure brevity in your answer.  90.55. What is the average Survival Rate(%) of Japan per year?
Offer a very short reply. 99.44. What is the average Survival Rate(%) in Madagascar per year?
Make the answer very short. 43.29. What is the average Survival Rate(%) in Nicaragua per year?
Give a very brief answer. 55.11. In the year 1971, what is the difference between the Survival Rate(%) in Argentina and Survival Rate(%) in Japan?
Give a very brief answer. -22.18. In the year 1971, what is the difference between the Survival Rate(%) in Argentina and Survival Rate(%) in Madagascar?
Provide a short and direct response. 47.86. In the year 1971, what is the difference between the Survival Rate(%) in Argentina and Survival Rate(%) in Nicaragua?
Provide a succinct answer. 46.22. In the year 1971, what is the difference between the Survival Rate(%) in Japan and Survival Rate(%) in Madagascar?
Your response must be concise. 70.04. In the year 1971, what is the difference between the Survival Rate(%) in Japan and Survival Rate(%) in Nicaragua?
Keep it short and to the point. 68.39. In the year 1971, what is the difference between the Survival Rate(%) of Madagascar and Survival Rate(%) of Nicaragua?
Ensure brevity in your answer.  -1.65. In the year 1999, what is the difference between the Survival Rate(%) in Argentina and Survival Rate(%) in Japan?
Offer a terse response. -7.71. In the year 1999, what is the difference between the Survival Rate(%) in Argentina and Survival Rate(%) in Madagascar?
Your answer should be compact. 39.61. In the year 1999, what is the difference between the Survival Rate(%) in Argentina and Survival Rate(%) in Nicaragua?
Provide a succinct answer. 39.35. In the year 1999, what is the difference between the Survival Rate(%) of Japan and Survival Rate(%) of Madagascar?
Offer a terse response. 47.32. In the year 1999, what is the difference between the Survival Rate(%) in Japan and Survival Rate(%) in Nicaragua?
Offer a very short reply. 47.06. In the year 1999, what is the difference between the Survival Rate(%) of Madagascar and Survival Rate(%) of Nicaragua?
Ensure brevity in your answer.  -0.26. In the year 2000, what is the difference between the Survival Rate(%) of Argentina and Survival Rate(%) of Japan?
Keep it short and to the point. -5.11. In the year 2000, what is the difference between the Survival Rate(%) of Argentina and Survival Rate(%) of Madagascar?
Ensure brevity in your answer.  57.67. In the year 2000, what is the difference between the Survival Rate(%) in Argentina and Survival Rate(%) in Nicaragua?
Give a very brief answer. 36.61. In the year 2000, what is the difference between the Survival Rate(%) of Japan and Survival Rate(%) of Madagascar?
Keep it short and to the point. 62.77. In the year 2000, what is the difference between the Survival Rate(%) of Japan and Survival Rate(%) of Nicaragua?
Provide a succinct answer. 41.72. In the year 2000, what is the difference between the Survival Rate(%) in Madagascar and Survival Rate(%) in Nicaragua?
Your answer should be compact. -21.05. In the year 2001, what is the difference between the Survival Rate(%) in Argentina and Survival Rate(%) in Japan?
Make the answer very short. -6.6. In the year 2001, what is the difference between the Survival Rate(%) in Argentina and Survival Rate(%) in Madagascar?
Give a very brief answer. 58.01. In the year 2001, what is the difference between the Survival Rate(%) in Argentina and Survival Rate(%) in Nicaragua?
Provide a short and direct response. 26.08. In the year 2001, what is the difference between the Survival Rate(%) of Japan and Survival Rate(%) of Madagascar?
Ensure brevity in your answer.  64.61. In the year 2001, what is the difference between the Survival Rate(%) in Japan and Survival Rate(%) in Nicaragua?
Offer a very short reply. 32.68. In the year 2001, what is the difference between the Survival Rate(%) in Madagascar and Survival Rate(%) in Nicaragua?
Offer a very short reply. -31.93. In the year 2002, what is the difference between the Survival Rate(%) of Argentina and Survival Rate(%) of Japan?
Give a very brief answer. -14.9. In the year 2002, what is the difference between the Survival Rate(%) in Argentina and Survival Rate(%) in Madagascar?
Offer a very short reply. 29.63. In the year 2002, what is the difference between the Survival Rate(%) in Argentina and Survival Rate(%) in Nicaragua?
Provide a succinct answer. 26.28. In the year 2002, what is the difference between the Survival Rate(%) of Japan and Survival Rate(%) of Madagascar?
Your answer should be compact. 44.53. In the year 2002, what is the difference between the Survival Rate(%) of Japan and Survival Rate(%) of Nicaragua?
Make the answer very short. 41.18. In the year 2002, what is the difference between the Survival Rate(%) in Madagascar and Survival Rate(%) in Nicaragua?
Give a very brief answer. -3.35. In the year 2003, what is the difference between the Survival Rate(%) of Argentina and Survival Rate(%) of Japan?
Your answer should be very brief. -2.5. In the year 2003, what is the difference between the Survival Rate(%) of Argentina and Survival Rate(%) of Madagascar?
Provide a short and direct response. 37.21. In the year 2003, what is the difference between the Survival Rate(%) of Argentina and Survival Rate(%) of Nicaragua?
Keep it short and to the point. 34.94. In the year 2003, what is the difference between the Survival Rate(%) in Japan and Survival Rate(%) in Madagascar?
Provide a succinct answer. 39.71. In the year 2003, what is the difference between the Survival Rate(%) in Japan and Survival Rate(%) in Nicaragua?
Your response must be concise. 37.44. In the year 2003, what is the difference between the Survival Rate(%) in Madagascar and Survival Rate(%) in Nicaragua?
Provide a short and direct response. -2.27. In the year 2004, what is the difference between the Survival Rate(%) in Argentina and Survival Rate(%) in Japan?
Make the answer very short. -8.92. In the year 2004, what is the difference between the Survival Rate(%) of Argentina and Survival Rate(%) of Madagascar?
Your answer should be very brief. 48.11. In the year 2004, what is the difference between the Survival Rate(%) of Argentina and Survival Rate(%) of Nicaragua?
Your answer should be very brief. 34.63. In the year 2004, what is the difference between the Survival Rate(%) of Japan and Survival Rate(%) of Madagascar?
Your answer should be compact. 57.03. In the year 2004, what is the difference between the Survival Rate(%) of Japan and Survival Rate(%) of Nicaragua?
Give a very brief answer. 43.55. In the year 2004, what is the difference between the Survival Rate(%) in Madagascar and Survival Rate(%) in Nicaragua?
Keep it short and to the point. -13.48. In the year 2005, what is the difference between the Survival Rate(%) in Argentina and Survival Rate(%) in Japan?
Your answer should be compact. -3.21. In the year 2005, what is the difference between the Survival Rate(%) in Argentina and Survival Rate(%) in Madagascar?
Offer a very short reply. 59.95. In the year 2005, what is the difference between the Survival Rate(%) in Argentina and Survival Rate(%) in Nicaragua?
Provide a succinct answer. 39.38. In the year 2005, what is the difference between the Survival Rate(%) of Japan and Survival Rate(%) of Madagascar?
Ensure brevity in your answer.  63.15. In the year 2005, what is the difference between the Survival Rate(%) in Japan and Survival Rate(%) in Nicaragua?
Your answer should be very brief. 42.58. In the year 2005, what is the difference between the Survival Rate(%) in Madagascar and Survival Rate(%) in Nicaragua?
Keep it short and to the point. -20.57. What is the ratio of the Survival Rate(%) of Argentina in 1971 to that in 1999?
Make the answer very short. 0.8. What is the ratio of the Survival Rate(%) in Japan in 1971 to that in 1999?
Make the answer very short. 0.96. What is the ratio of the Survival Rate(%) in Madagascar in 1971 to that in 1999?
Offer a terse response. 0.49. What is the ratio of the Survival Rate(%) of Nicaragua in 1971 to that in 1999?
Provide a short and direct response. 0.52. What is the ratio of the Survival Rate(%) in Argentina in 1971 to that in 2000?
Offer a very short reply. 0.78. What is the ratio of the Survival Rate(%) of Japan in 1971 to that in 2000?
Make the answer very short. 0.96. What is the ratio of the Survival Rate(%) of Madagascar in 1971 to that in 2000?
Make the answer very short. 0.69. What is the ratio of the Survival Rate(%) in Nicaragua in 1971 to that in 2000?
Your response must be concise. 0.47. What is the ratio of the Survival Rate(%) of Argentina in 1971 to that in 2001?
Your answer should be compact. 0.79. What is the ratio of the Survival Rate(%) in Japan in 1971 to that in 2001?
Keep it short and to the point. 0.96. What is the ratio of the Survival Rate(%) in Madagascar in 1971 to that in 2001?
Give a very brief answer. 0.73. What is the ratio of the Survival Rate(%) of Nicaragua in 1971 to that in 2001?
Keep it short and to the point. 0.41. What is the ratio of the Survival Rate(%) in Argentina in 1971 to that in 2002?
Make the answer very short. 0.86. What is the ratio of the Survival Rate(%) in Japan in 1971 to that in 2002?
Ensure brevity in your answer.  0.96. What is the ratio of the Survival Rate(%) of Madagascar in 1971 to that in 2002?
Offer a terse response. 0.46. What is the ratio of the Survival Rate(%) in Nicaragua in 1971 to that in 2002?
Provide a short and direct response. 0.47. What is the ratio of the Survival Rate(%) in Argentina in 1971 to that in 2003?
Your response must be concise. 0.75. What is the ratio of the Survival Rate(%) in Japan in 1971 to that in 2003?
Offer a very short reply. 0.96. What is the ratio of the Survival Rate(%) of Madagascar in 1971 to that in 2003?
Offer a very short reply. 0.43. What is the ratio of the Survival Rate(%) of Nicaragua in 1971 to that in 2003?
Your response must be concise. 0.44. What is the ratio of the Survival Rate(%) of Argentina in 1971 to that in 2004?
Ensure brevity in your answer.  0.81. What is the ratio of the Survival Rate(%) of Japan in 1971 to that in 2004?
Your response must be concise. 0.96. What is the ratio of the Survival Rate(%) in Madagascar in 1971 to that in 2004?
Keep it short and to the point. 0.6. What is the ratio of the Survival Rate(%) of Nicaragua in 1971 to that in 2004?
Your answer should be compact. 0.49. What is the ratio of the Survival Rate(%) in Argentina in 1971 to that in 2005?
Your response must be concise. 0.76. What is the ratio of the Survival Rate(%) of Japan in 1971 to that in 2005?
Your answer should be compact. 0.96. What is the ratio of the Survival Rate(%) in Madagascar in 1971 to that in 2005?
Your answer should be compact. 0.7. What is the ratio of the Survival Rate(%) in Nicaragua in 1971 to that in 2005?
Your answer should be compact. 0.48. What is the ratio of the Survival Rate(%) of Argentina in 1999 to that in 2000?
Your response must be concise. 0.97. What is the ratio of the Survival Rate(%) in Japan in 1999 to that in 2000?
Provide a short and direct response. 1. What is the ratio of the Survival Rate(%) in Madagascar in 1999 to that in 2000?
Offer a very short reply. 1.41. What is the ratio of the Survival Rate(%) in Nicaragua in 1999 to that in 2000?
Provide a short and direct response. 0.91. What is the ratio of the Survival Rate(%) of Argentina in 1999 to that in 2001?
Offer a terse response. 0.99. What is the ratio of the Survival Rate(%) in Madagascar in 1999 to that in 2001?
Your answer should be very brief. 1.49. What is the ratio of the Survival Rate(%) of Nicaragua in 1999 to that in 2001?
Your answer should be very brief. 0.79. What is the ratio of the Survival Rate(%) of Argentina in 1999 to that in 2002?
Your answer should be compact. 1.08. What is the ratio of the Survival Rate(%) in Japan in 1999 to that in 2002?
Your answer should be compact. 1. What is the ratio of the Survival Rate(%) of Madagascar in 1999 to that in 2002?
Offer a very short reply. 0.95. What is the ratio of the Survival Rate(%) of Nicaragua in 1999 to that in 2002?
Provide a succinct answer. 0.9. What is the ratio of the Survival Rate(%) in Argentina in 1999 to that in 2003?
Offer a very short reply. 0.95. What is the ratio of the Survival Rate(%) of Japan in 1999 to that in 2003?
Provide a short and direct response. 1. What is the ratio of the Survival Rate(%) in Madagascar in 1999 to that in 2003?
Ensure brevity in your answer.  0.87. What is the ratio of the Survival Rate(%) in Nicaragua in 1999 to that in 2003?
Ensure brevity in your answer.  0.85. What is the ratio of the Survival Rate(%) in Argentina in 1999 to that in 2004?
Offer a terse response. 1.01. What is the ratio of the Survival Rate(%) of Japan in 1999 to that in 2004?
Your response must be concise. 1. What is the ratio of the Survival Rate(%) of Madagascar in 1999 to that in 2004?
Provide a succinct answer. 1.23. What is the ratio of the Survival Rate(%) of Nicaragua in 1999 to that in 2004?
Provide a succinct answer. 0.94. What is the ratio of the Survival Rate(%) of Argentina in 1999 to that in 2005?
Provide a short and direct response. 0.95. What is the ratio of the Survival Rate(%) of Madagascar in 1999 to that in 2005?
Offer a terse response. 1.43. What is the ratio of the Survival Rate(%) of Nicaragua in 1999 to that in 2005?
Offer a terse response. 0.92. What is the ratio of the Survival Rate(%) of Argentina in 2000 to that in 2001?
Offer a very short reply. 1.02. What is the ratio of the Survival Rate(%) of Madagascar in 2000 to that in 2001?
Offer a terse response. 1.05. What is the ratio of the Survival Rate(%) in Nicaragua in 2000 to that in 2001?
Your answer should be compact. 0.87. What is the ratio of the Survival Rate(%) of Argentina in 2000 to that in 2002?
Provide a short and direct response. 1.12. What is the ratio of the Survival Rate(%) of Madagascar in 2000 to that in 2002?
Your answer should be compact. 0.67. What is the ratio of the Survival Rate(%) of Argentina in 2000 to that in 2003?
Your response must be concise. 0.97. What is the ratio of the Survival Rate(%) in Madagascar in 2000 to that in 2003?
Offer a terse response. 0.62. What is the ratio of the Survival Rate(%) in Nicaragua in 2000 to that in 2003?
Make the answer very short. 0.93. What is the ratio of the Survival Rate(%) in Argentina in 2000 to that in 2004?
Your answer should be compact. 1.04. What is the ratio of the Survival Rate(%) of Madagascar in 2000 to that in 2004?
Offer a very short reply. 0.87. What is the ratio of the Survival Rate(%) of Nicaragua in 2000 to that in 2004?
Your answer should be compact. 1.03. What is the ratio of the Survival Rate(%) of Argentina in 2000 to that in 2005?
Keep it short and to the point. 0.98. What is the ratio of the Survival Rate(%) in Madagascar in 2000 to that in 2005?
Provide a short and direct response. 1.01. What is the ratio of the Survival Rate(%) of Nicaragua in 2000 to that in 2005?
Offer a very short reply. 1.02. What is the ratio of the Survival Rate(%) of Argentina in 2001 to that in 2002?
Provide a short and direct response. 1.1. What is the ratio of the Survival Rate(%) in Madagascar in 2001 to that in 2002?
Offer a terse response. 0.64. What is the ratio of the Survival Rate(%) in Nicaragua in 2001 to that in 2002?
Your answer should be very brief. 1.14. What is the ratio of the Survival Rate(%) of Argentina in 2001 to that in 2003?
Make the answer very short. 0.96. What is the ratio of the Survival Rate(%) in Japan in 2001 to that in 2003?
Ensure brevity in your answer.  1. What is the ratio of the Survival Rate(%) of Madagascar in 2001 to that in 2003?
Provide a short and direct response. 0.59. What is the ratio of the Survival Rate(%) in Nicaragua in 2001 to that in 2003?
Make the answer very short. 1.08. What is the ratio of the Survival Rate(%) of Argentina in 2001 to that in 2004?
Provide a succinct answer. 1.03. What is the ratio of the Survival Rate(%) of Japan in 2001 to that in 2004?
Your answer should be compact. 1. What is the ratio of the Survival Rate(%) of Madagascar in 2001 to that in 2004?
Your answer should be very brief. 0.82. What is the ratio of the Survival Rate(%) in Nicaragua in 2001 to that in 2004?
Your answer should be compact. 1.19. What is the ratio of the Survival Rate(%) of Argentina in 2001 to that in 2005?
Keep it short and to the point. 0.97. What is the ratio of the Survival Rate(%) in Japan in 2001 to that in 2005?
Give a very brief answer. 1. What is the ratio of the Survival Rate(%) of Madagascar in 2001 to that in 2005?
Your response must be concise. 0.96. What is the ratio of the Survival Rate(%) of Nicaragua in 2001 to that in 2005?
Your answer should be compact. 1.17. What is the ratio of the Survival Rate(%) in Argentina in 2002 to that in 2003?
Your response must be concise. 0.87. What is the ratio of the Survival Rate(%) of Japan in 2002 to that in 2003?
Provide a succinct answer. 1. What is the ratio of the Survival Rate(%) in Madagascar in 2002 to that in 2003?
Your answer should be very brief. 0.92. What is the ratio of the Survival Rate(%) of Nicaragua in 2002 to that in 2003?
Offer a terse response. 0.94. What is the ratio of the Survival Rate(%) in Argentina in 2002 to that in 2004?
Make the answer very short. 0.93. What is the ratio of the Survival Rate(%) of Japan in 2002 to that in 2004?
Keep it short and to the point. 1. What is the ratio of the Survival Rate(%) of Madagascar in 2002 to that in 2004?
Offer a terse response. 1.29. What is the ratio of the Survival Rate(%) in Nicaragua in 2002 to that in 2004?
Ensure brevity in your answer.  1.04. What is the ratio of the Survival Rate(%) in Argentina in 2002 to that in 2005?
Provide a short and direct response. 0.88. What is the ratio of the Survival Rate(%) of Japan in 2002 to that in 2005?
Your answer should be very brief. 1. What is the ratio of the Survival Rate(%) in Madagascar in 2002 to that in 2005?
Offer a very short reply. 1.51. What is the ratio of the Survival Rate(%) of Nicaragua in 2002 to that in 2005?
Give a very brief answer. 1.03. What is the ratio of the Survival Rate(%) in Argentina in 2003 to that in 2004?
Your answer should be compact. 1.07. What is the ratio of the Survival Rate(%) in Madagascar in 2003 to that in 2004?
Give a very brief answer. 1.4. What is the ratio of the Survival Rate(%) of Nicaragua in 2003 to that in 2004?
Make the answer very short. 1.11. What is the ratio of the Survival Rate(%) in Argentina in 2003 to that in 2005?
Keep it short and to the point. 1.01. What is the ratio of the Survival Rate(%) in Japan in 2003 to that in 2005?
Ensure brevity in your answer.  1. What is the ratio of the Survival Rate(%) in Madagascar in 2003 to that in 2005?
Provide a succinct answer. 1.64. What is the ratio of the Survival Rate(%) in Nicaragua in 2003 to that in 2005?
Offer a terse response. 1.09. What is the ratio of the Survival Rate(%) of Japan in 2004 to that in 2005?
Your response must be concise. 1. What is the ratio of the Survival Rate(%) in Madagascar in 2004 to that in 2005?
Make the answer very short. 1.17. What is the ratio of the Survival Rate(%) of Nicaragua in 2004 to that in 2005?
Provide a short and direct response. 0.98. What is the difference between the highest and the second highest Survival Rate(%) of Argentina?
Keep it short and to the point. 0.76. What is the difference between the highest and the second highest Survival Rate(%) of Japan?
Your answer should be compact. 0.01. What is the difference between the highest and the second highest Survival Rate(%) in Madagascar?
Ensure brevity in your answer.  4.82. What is the difference between the highest and the second highest Survival Rate(%) of Nicaragua?
Keep it short and to the point. 4.74. What is the difference between the highest and the lowest Survival Rate(%) in Argentina?
Your response must be concise. 23.9. What is the difference between the highest and the lowest Survival Rate(%) in Japan?
Give a very brief answer. 4.24. What is the difference between the highest and the lowest Survival Rate(%) of Madagascar?
Offer a terse response. 34.55. What is the difference between the highest and the lowest Survival Rate(%) in Nicaragua?
Make the answer very short. 39.92. 